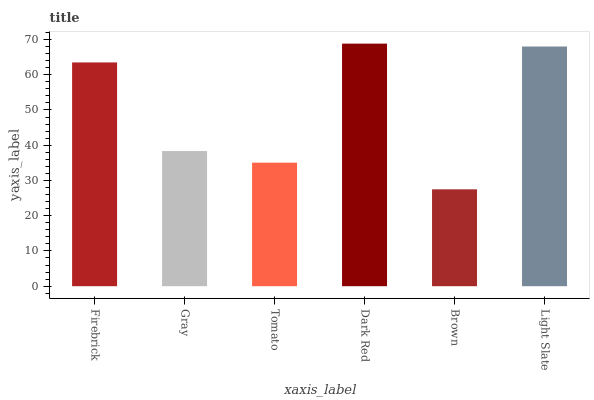Is Gray the minimum?
Answer yes or no. No. Is Gray the maximum?
Answer yes or no. No. Is Firebrick greater than Gray?
Answer yes or no. Yes. Is Gray less than Firebrick?
Answer yes or no. Yes. Is Gray greater than Firebrick?
Answer yes or no. No. Is Firebrick less than Gray?
Answer yes or no. No. Is Firebrick the high median?
Answer yes or no. Yes. Is Gray the low median?
Answer yes or no. Yes. Is Light Slate the high median?
Answer yes or no. No. Is Brown the low median?
Answer yes or no. No. 